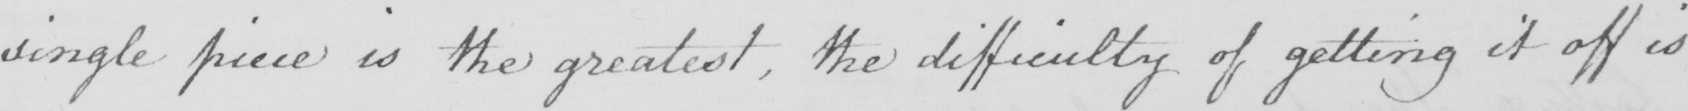Please transcribe the handwritten text in this image. single piece is the greatest, the difficulty of getting it off is 